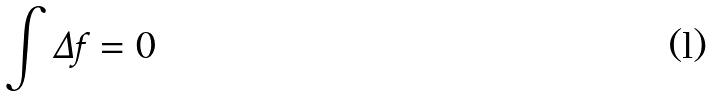Convert formula to latex. <formula><loc_0><loc_0><loc_500><loc_500>\int \Delta f = 0</formula> 